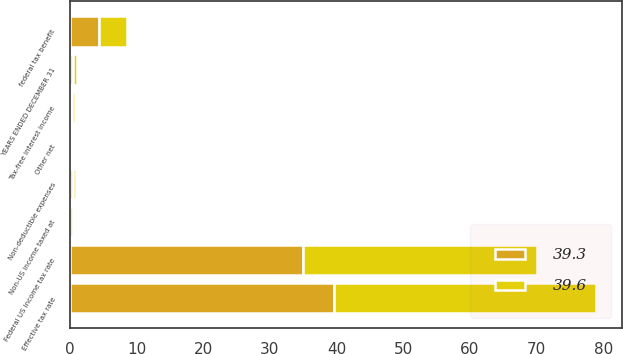Convert chart. <chart><loc_0><loc_0><loc_500><loc_500><stacked_bar_chart><ecel><fcel>YEARS ENDED DECEMBER 31<fcel>Federal US income tax rate<fcel>federal tax benefit<fcel>Tax-free interest income<fcel>Non-deductible expenses<fcel>Non-US income taxed at<fcel>Other net<fcel>Effective tax rate<nl><fcel>39.3<fcel>0.5<fcel>35<fcel>4.3<fcel>0.3<fcel>0.5<fcel>0.5<fcel>0.1<fcel>39.6<nl><fcel>39.6<fcel>0.5<fcel>35<fcel>4.2<fcel>0.5<fcel>0.4<fcel>0.1<fcel>0.1<fcel>39.3<nl></chart> 